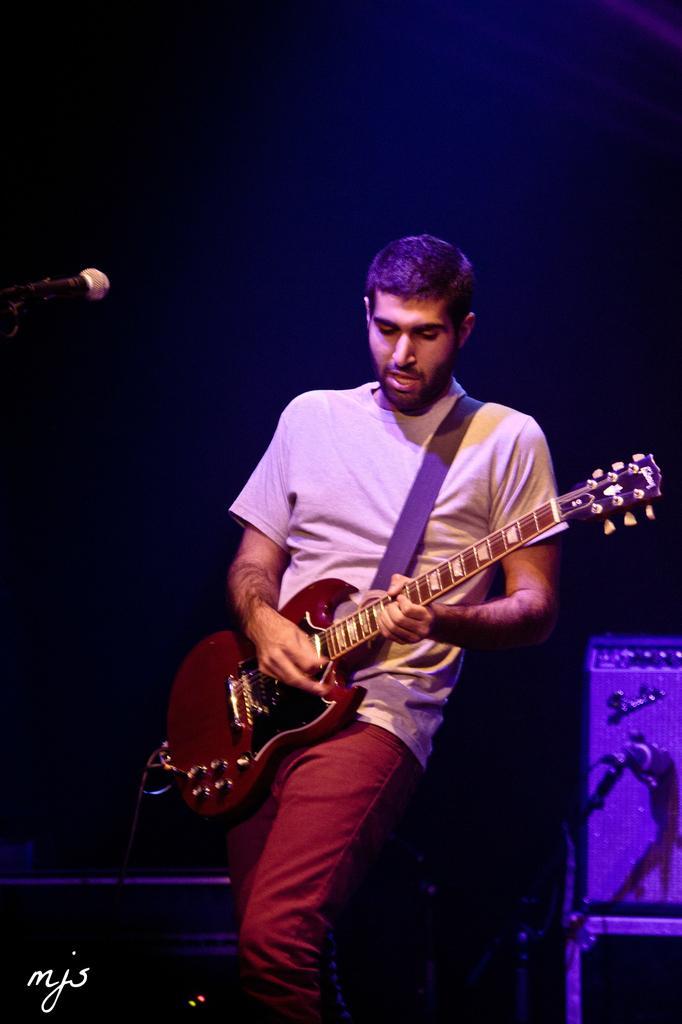Please provide a concise description of this image. in this image the person is holding the guitar and he is singing the song in front of mike below left corner some text is there he is wearing the white t-shirt and red pant and the back ground is very dark. 